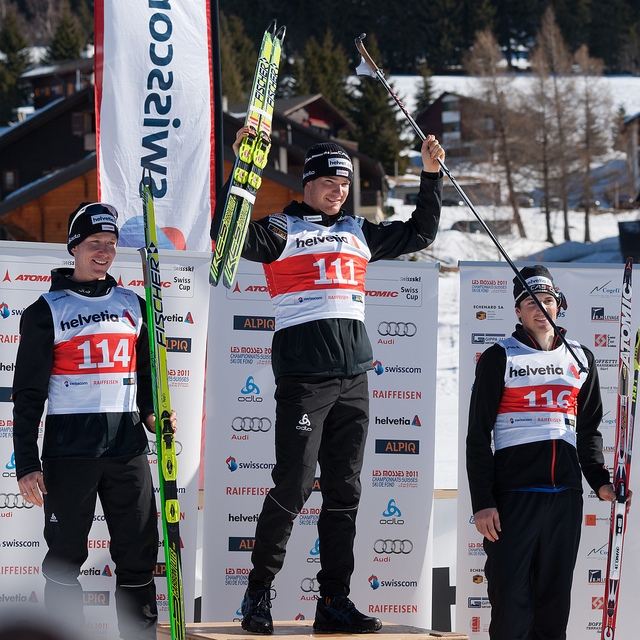What emotions are being expressed by the people in the photograph? The central figure, standing at the top of the podium, is exuding joy and a sense of accomplishment, emphasized by the raised arm and the triumphant fist around the ski pole. The expressions of the other two individuals suggest modest happiness. They are smiling, but their body language is more reserved, likely indicating that they are pleased with their performance but also respectful of the competition and the winner. 